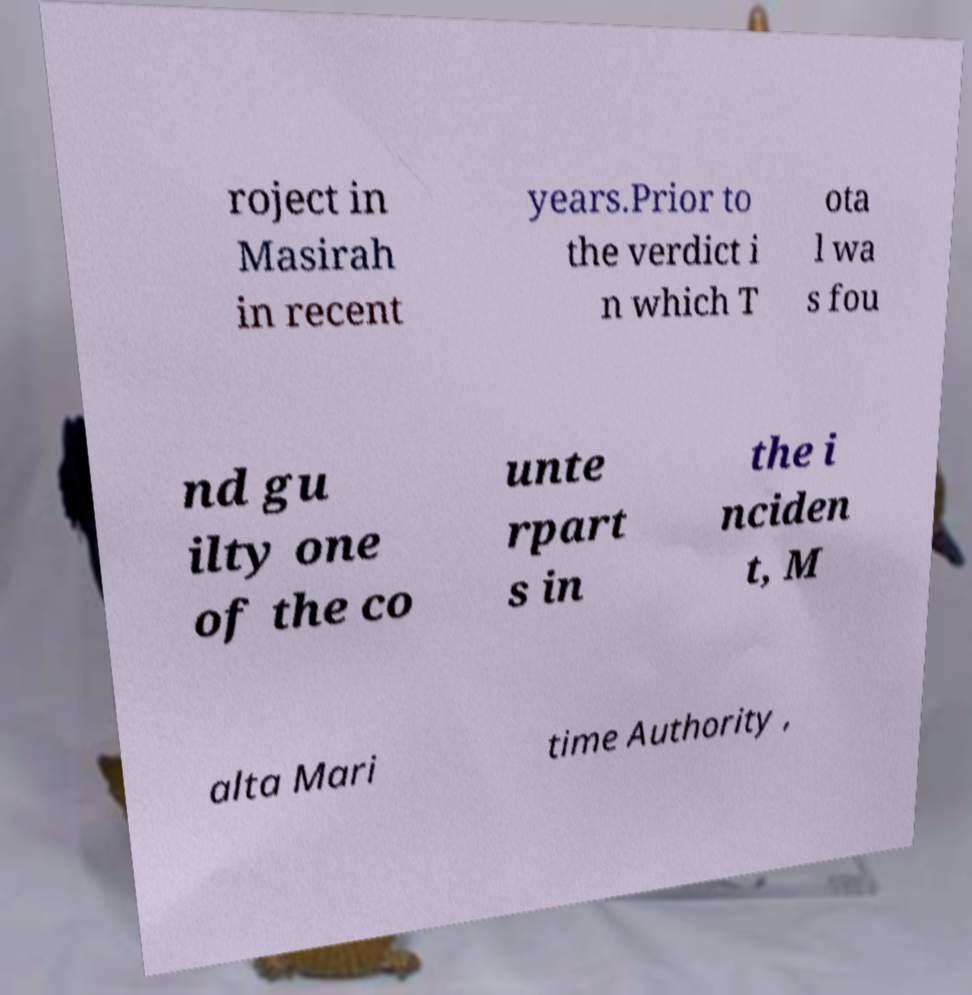Could you assist in decoding the text presented in this image and type it out clearly? roject in Masirah in recent years.Prior to the verdict i n which T ota l wa s fou nd gu ilty one of the co unte rpart s in the i nciden t, M alta Mari time Authority , 